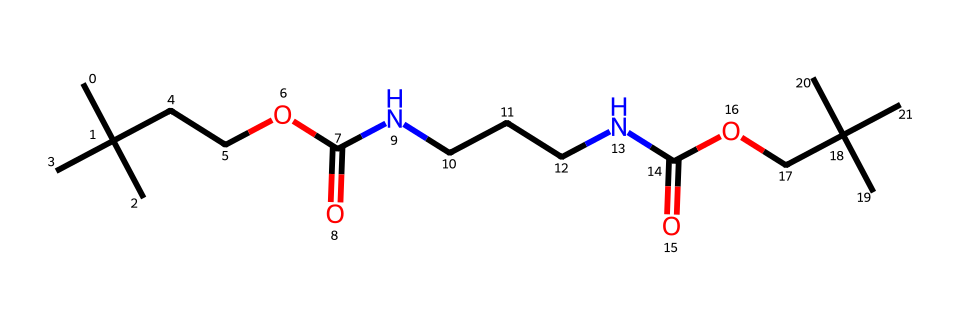how many carbon atoms are present in the chemical? Count the number of 'C' symbols in the SMILES representation. In the provided SMILES, there are 16 'C' symbols, indicating 16 carbon atoms.
Answer: 16 what type of polymer does this structure represent? The presence of repeating units and a backbone with functional groups suggests that this structure is a type of polyurethane polymer, commonly used in memory foam.
Answer: polyurethane how many nitrogen atoms are present in the chemical? Identify the number of 'N' symbols in the SMILES representation. There are 3 'N' symbols, which indicates there are 3 nitrogen atoms in the structure.
Answer: 3 what functional group is associated with the ester in this polymer? The ester functional group is indicated by the 'OC(=O)' part of the SMILES. This suggests that the structure includes an ester link, typical in polyurethanes.
Answer: ester which part of the polymer contributes to its flexibility? The presence of soft segments, specifically the aliphatic carbon chains and ester groups allows for increased flexibility in the polymer structure.
Answer: soft segments how many oxygen atoms are included in this structure? Count the number of 'O' symbols in the SMILES representation. There are 4 'O' symbols, indicating 4 oxygen atoms present in the chemical.
Answer: 4 what is the significance of the amine groups in this polymer? The amine groups provide sites for cross-linking within the polymer backbone, contributing to the overall structure and mechanical properties of the memory foam.
Answer: cross-linking 